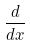Convert formula to latex. <formula><loc_0><loc_0><loc_500><loc_500>\frac { d } { d x }</formula> 